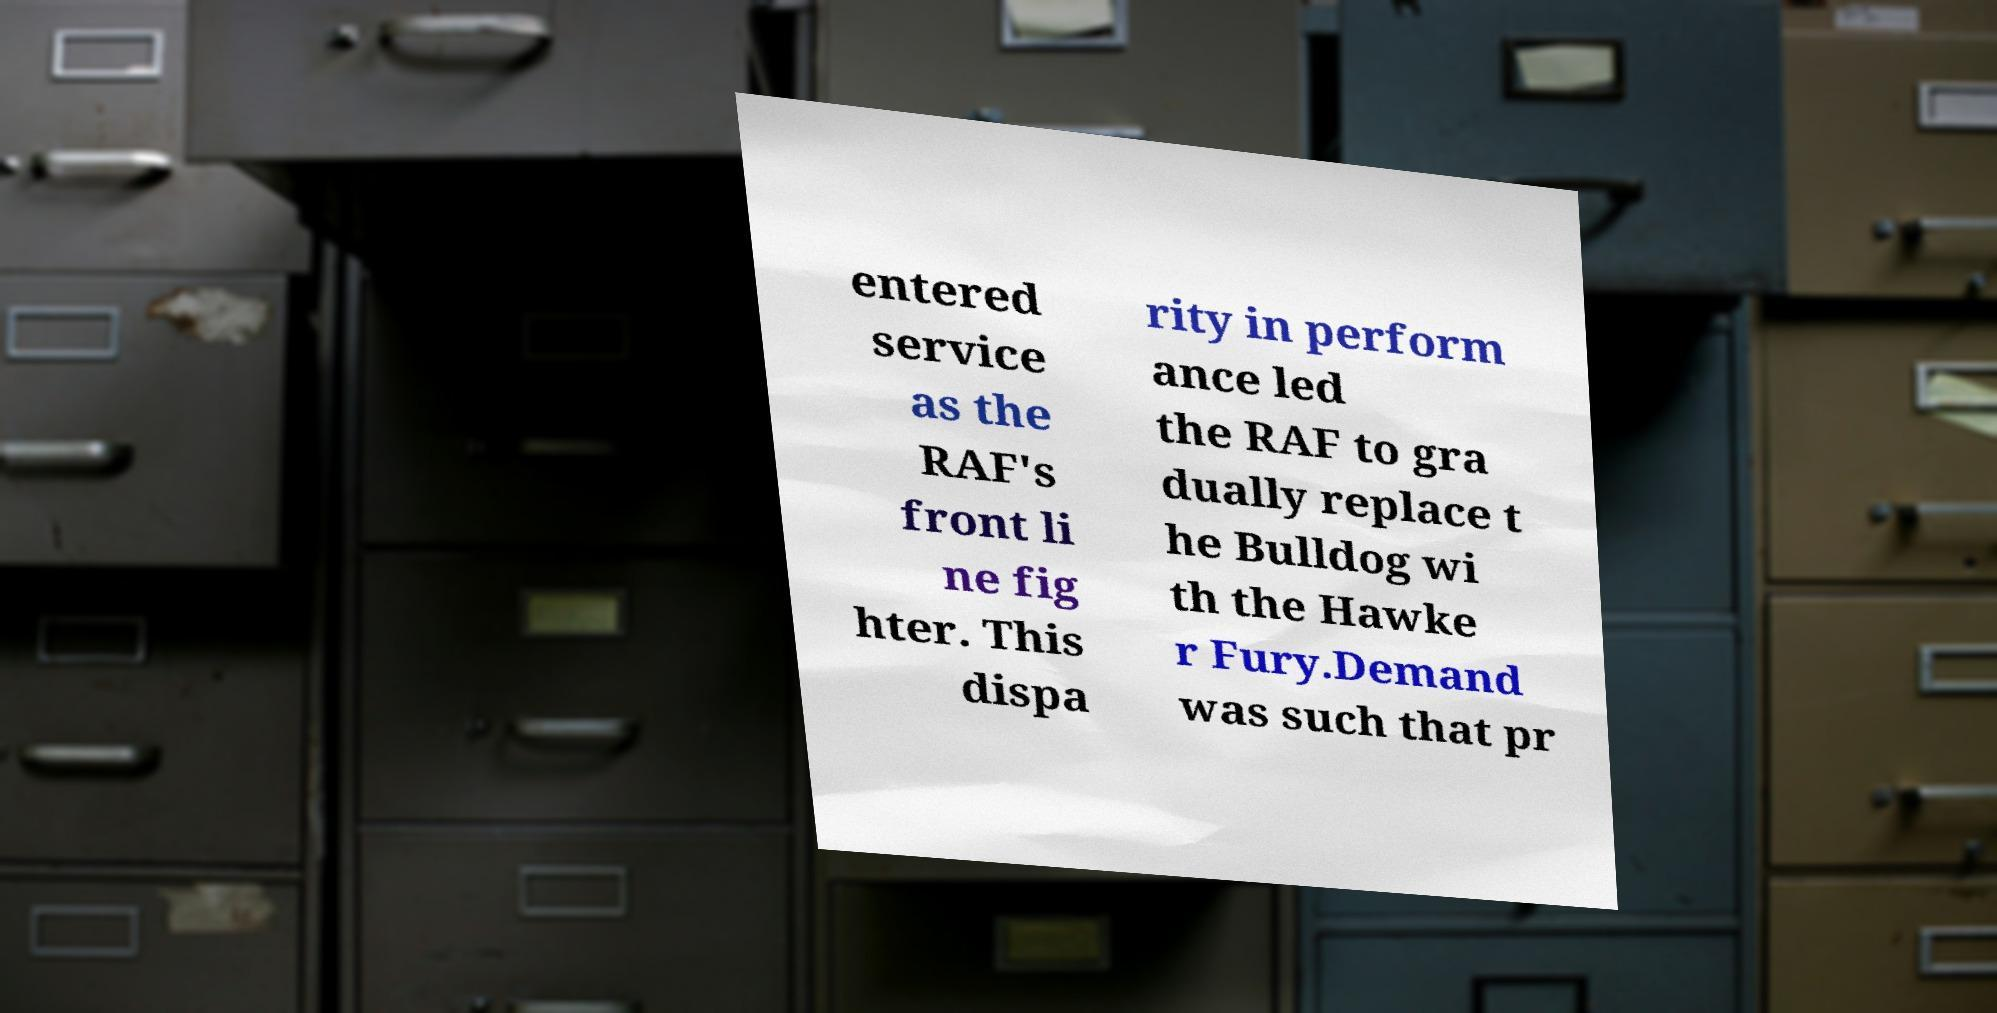Please read and relay the text visible in this image. What does it say? entered service as the RAF's front li ne fig hter. This dispa rity in perform ance led the RAF to gra dually replace t he Bulldog wi th the Hawke r Fury.Demand was such that pr 